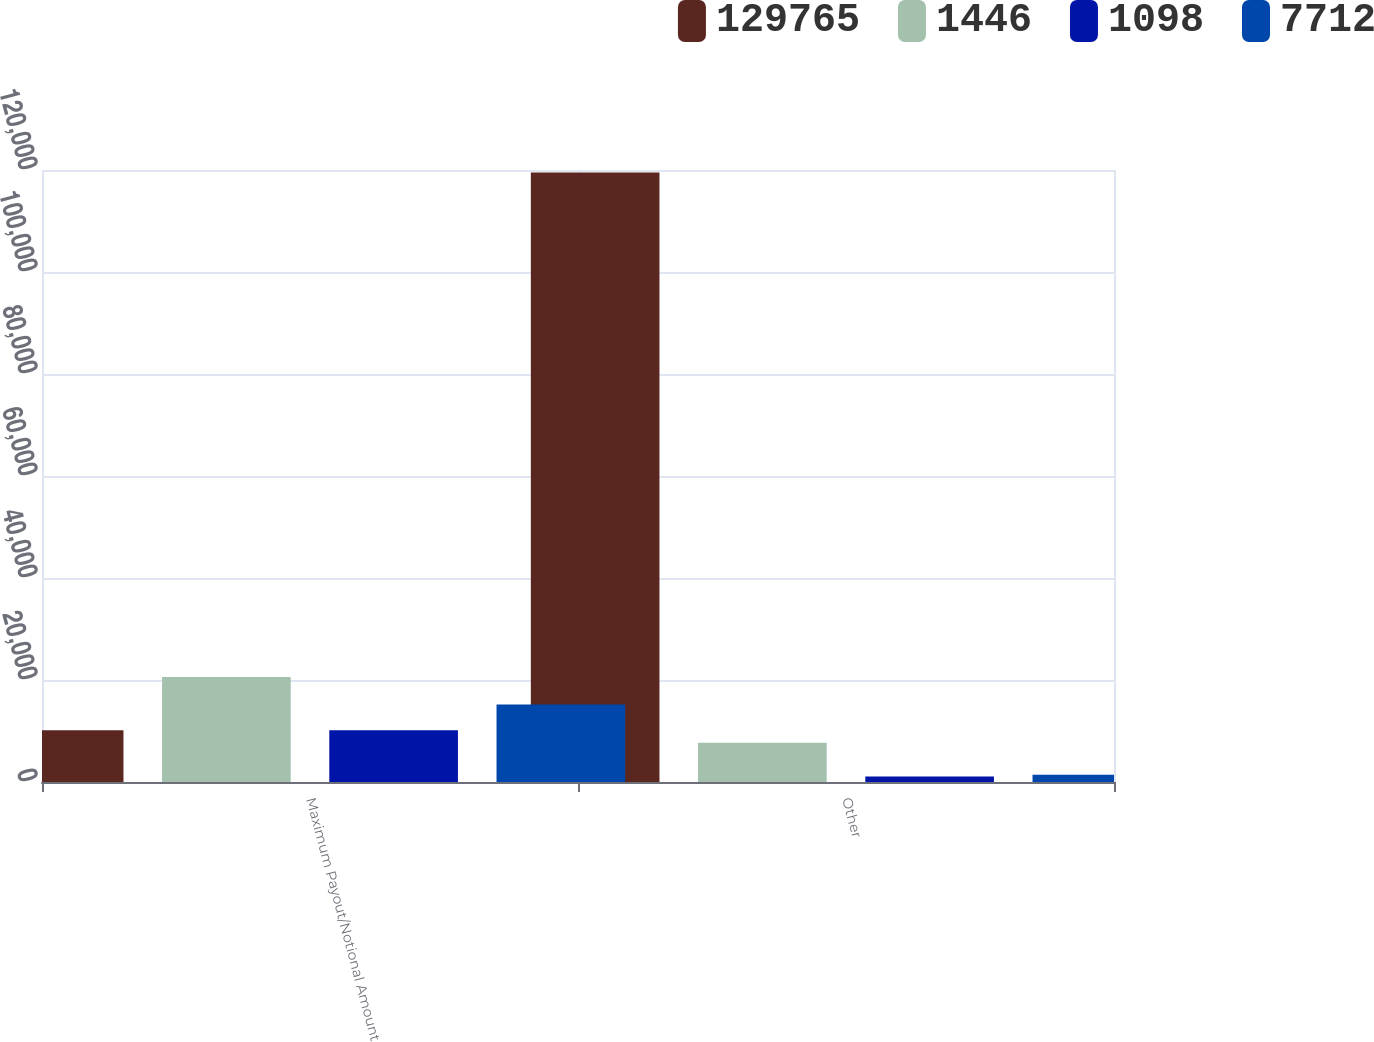Convert chart. <chart><loc_0><loc_0><loc_500><loc_500><stacked_bar_chart><ecel><fcel>Maximum Payout/Notional Amount<fcel>Other<nl><fcel>129765<fcel>10133<fcel>119509<nl><fcel>1446<fcel>20588<fcel>7712<nl><fcel>1098<fcel>10133<fcel>1098<nl><fcel>7712<fcel>15186<fcel>1446<nl></chart> 